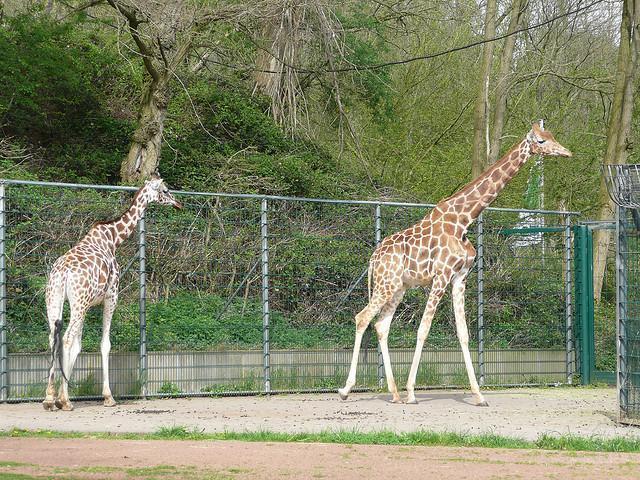How many giraffes are in this scene?
Give a very brief answer. 2. How many ostriches are there?
Give a very brief answer. 0. How many giraffes are in the picture?
Give a very brief answer. 2. How many species are seen?
Give a very brief answer. 1. How many giraffes can be seen?
Give a very brief answer. 2. How many eyelashes does the cat have?
Give a very brief answer. 0. 